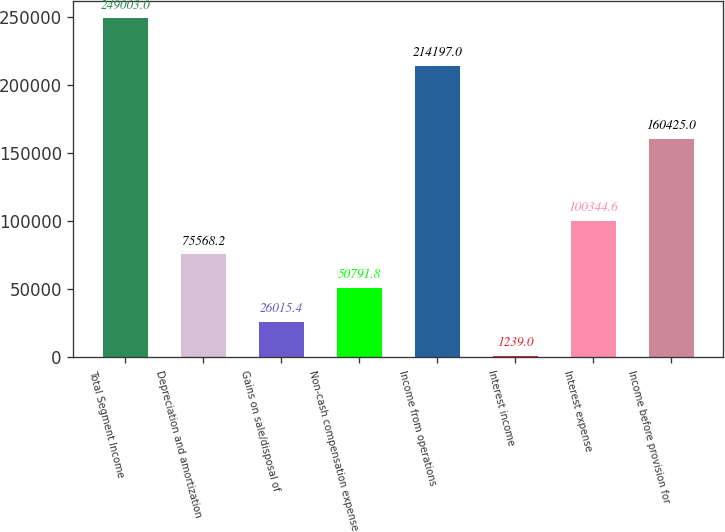Convert chart. <chart><loc_0><loc_0><loc_500><loc_500><bar_chart><fcel>Total Segment Income<fcel>Depreciation and amortization<fcel>Gains on sale/disposal of<fcel>Non-cash compensation expense<fcel>Income from operations<fcel>Interest income<fcel>Interest expense<fcel>Income before provision for<nl><fcel>249003<fcel>75568.2<fcel>26015.4<fcel>50791.8<fcel>214197<fcel>1239<fcel>100345<fcel>160425<nl></chart> 